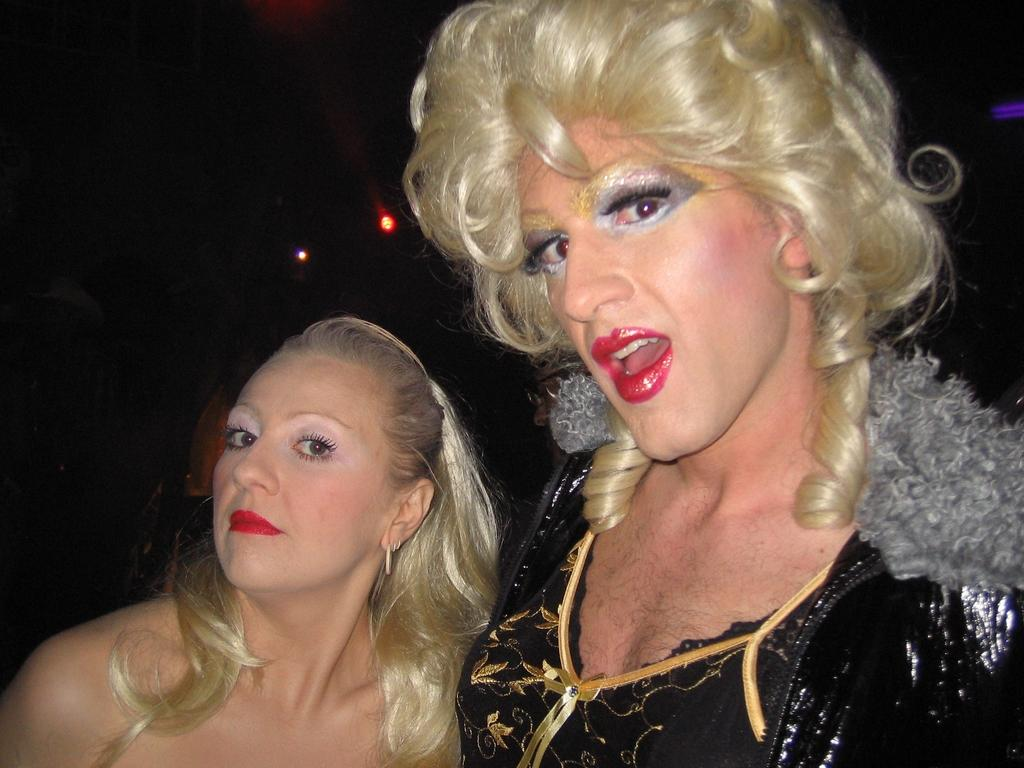How many people are in the image? There are two persons in the image. What can be observed about the positioning of the persons in the image? The persons are truncated towards the bottom of the image. What type of illumination is present in the image? There are lights in the image. What is the color of the background in the image? The background of the image is dark. What type of hose is being used by the persons in the image? There is no hose present in the image. What is the persons carrying in a bag in the image? There is no bag or any items being carried by the persons in the image. 